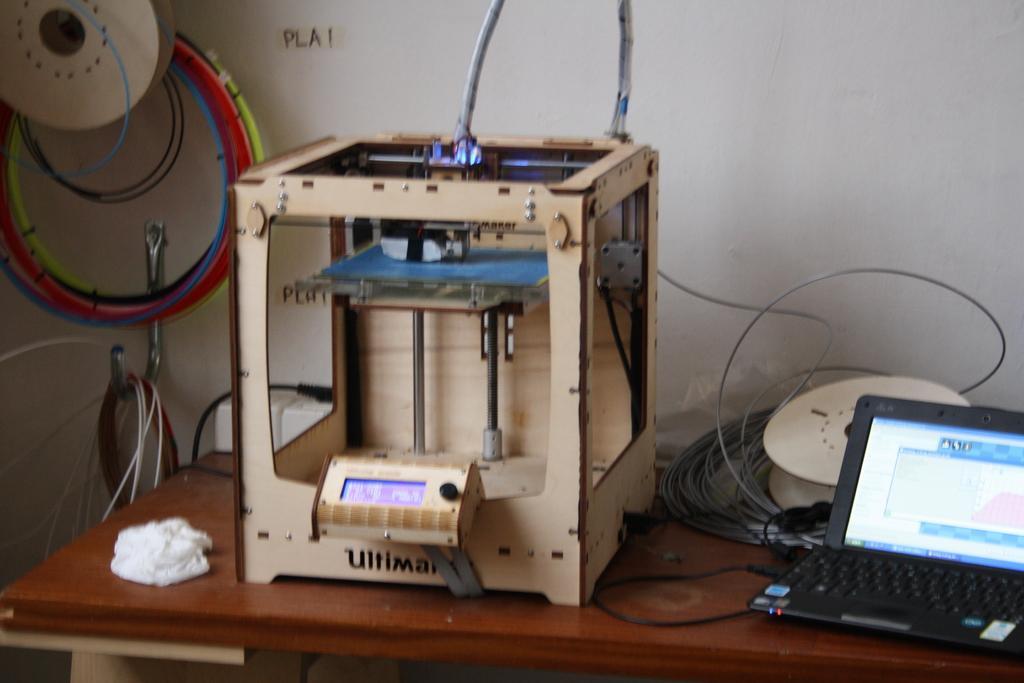Can you describe this image briefly? In this image we can see a table. On table machine, wires, laptop and white color thing is present. Left side of the image wires are present. Behind the table white color wall is there. 